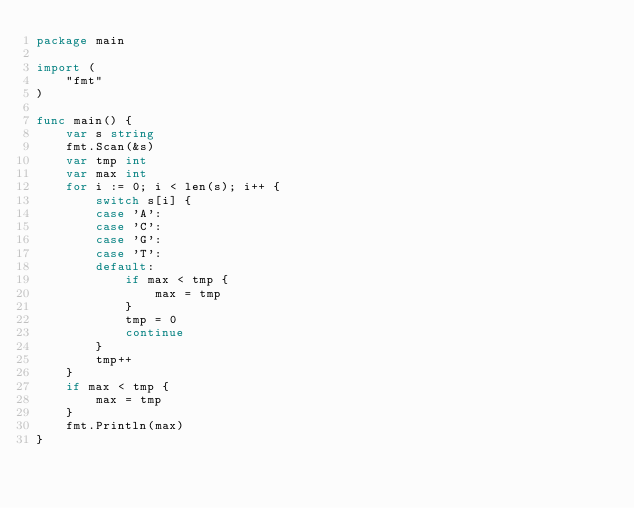Convert code to text. <code><loc_0><loc_0><loc_500><loc_500><_Go_>package main

import (
	"fmt"
)

func main() {
	var s string
	fmt.Scan(&s)
	var tmp int
	var max int
	for i := 0; i < len(s); i++ {
		switch s[i] {
		case 'A':
		case 'C':
		case 'G':
		case 'T':
		default:
			if max < tmp {
				max = tmp
			}
			tmp = 0
			continue
		}
		tmp++
	}
	if max < tmp {
		max = tmp
	}
	fmt.Println(max)
}</code> 